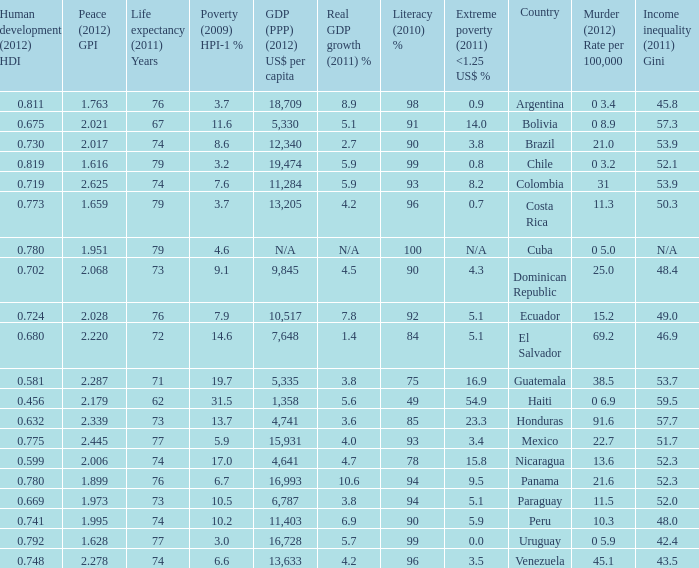What is the total poverty (2009) HPI-1 % when the extreme poverty (2011) <1.25 US$ % of 16.9, and the human development (2012) HDI is less than 0.581? None. 